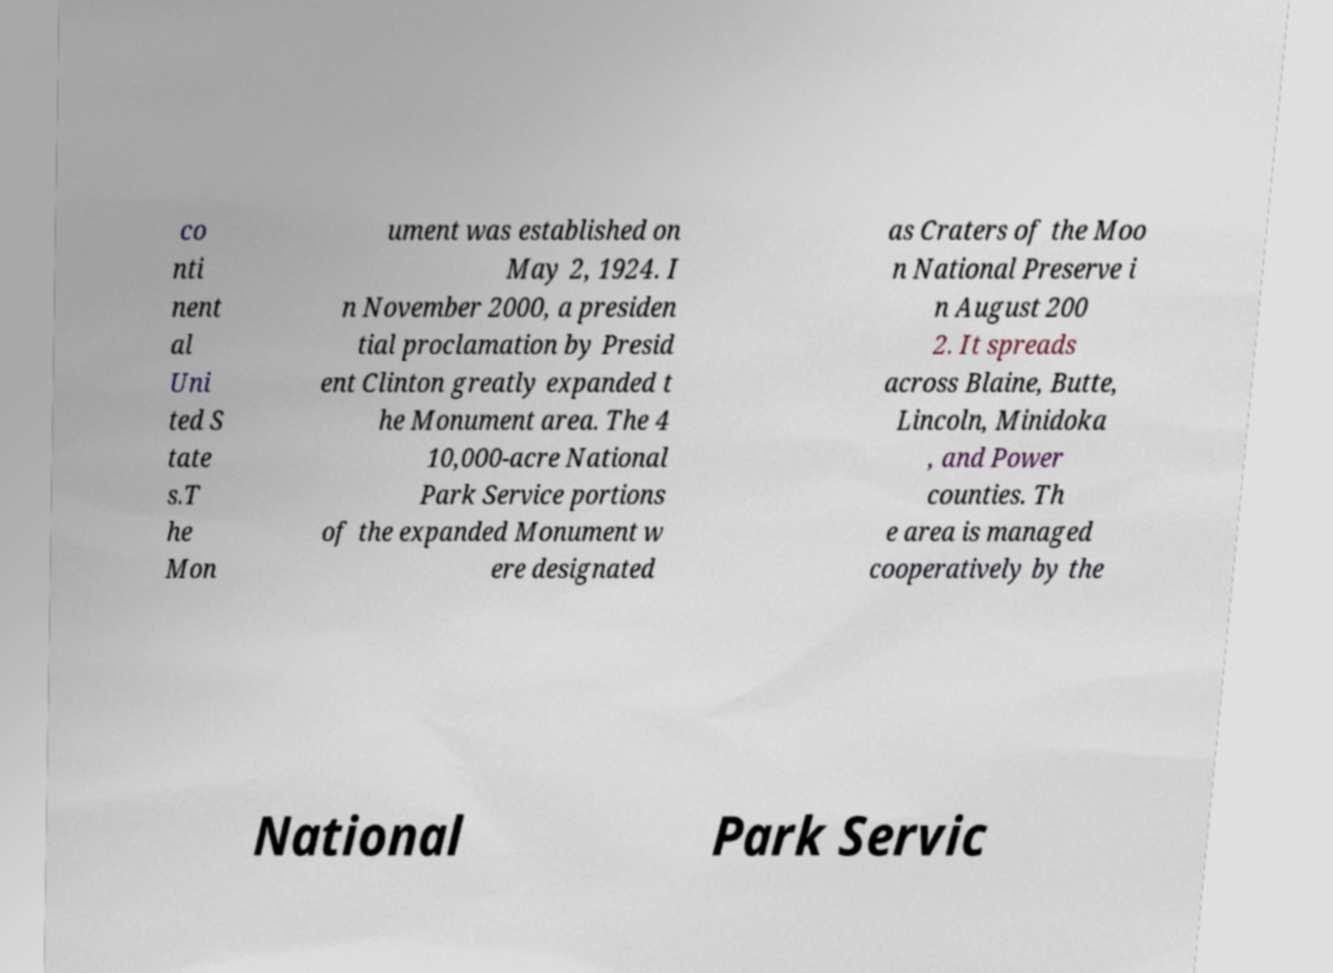Could you assist in decoding the text presented in this image and type it out clearly? co nti nent al Uni ted S tate s.T he Mon ument was established on May 2, 1924. I n November 2000, a presiden tial proclamation by Presid ent Clinton greatly expanded t he Monument area. The 4 10,000-acre National Park Service portions of the expanded Monument w ere designated as Craters of the Moo n National Preserve i n August 200 2. It spreads across Blaine, Butte, Lincoln, Minidoka , and Power counties. Th e area is managed cooperatively by the National Park Servic 